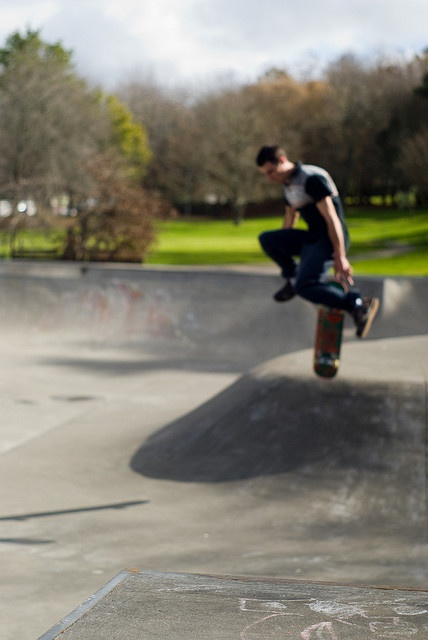Describe the objects in this image and their specific colors. I can see people in lavender, black, gray, and maroon tones and skateboard in lavender, black, gray, and maroon tones in this image. 